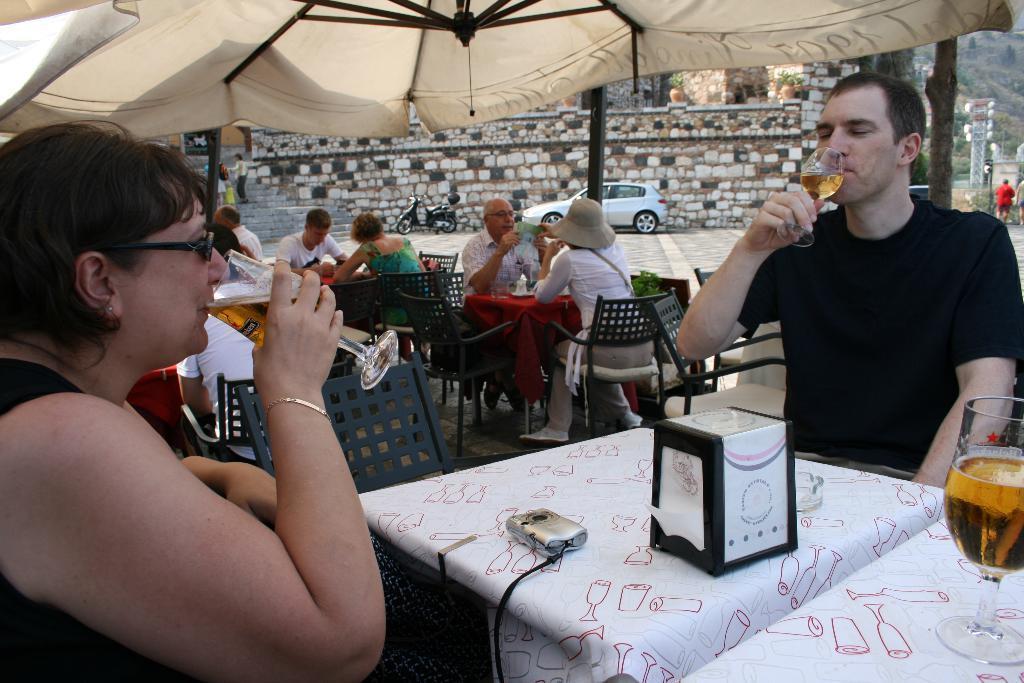Describe this image in one or two sentences. In this image there is a table which is covered with a white cloth, And on that there is a glass which contains alcohol and a man sitting on the chair drinks alcohol and a woman siting infront of him she is also drinking alcohol and in there are some peoples sitting on the chair in the background there is a wall ,there is a car, there is a scooter and some stairs. 